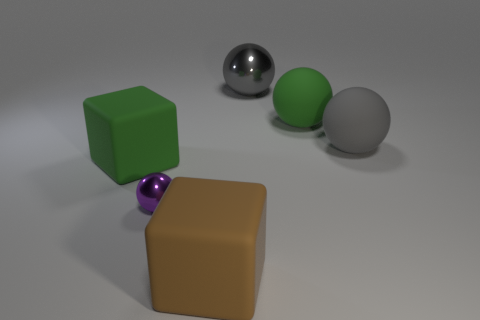There is a large brown thing; is its shape the same as the green rubber thing that is to the right of the brown matte thing?
Offer a very short reply. No. Are there any other things that are the same color as the small object?
Provide a succinct answer. No. Do the matte block right of the green block and the metal sphere in front of the green cube have the same color?
Give a very brief answer. No. Is there a large brown rubber cube?
Ensure brevity in your answer.  Yes. Is there a tiny sphere made of the same material as the large green block?
Offer a very short reply. No. Is there any other thing that is the same material as the big green sphere?
Give a very brief answer. Yes. What color is the small metallic sphere?
Keep it short and to the point. Purple. There is a metallic ball that is the same size as the green block; what color is it?
Ensure brevity in your answer.  Gray. How many rubber things are either brown spheres or large brown cubes?
Give a very brief answer. 1. How many things are both right of the small thing and to the left of the large green rubber ball?
Ensure brevity in your answer.  2. 